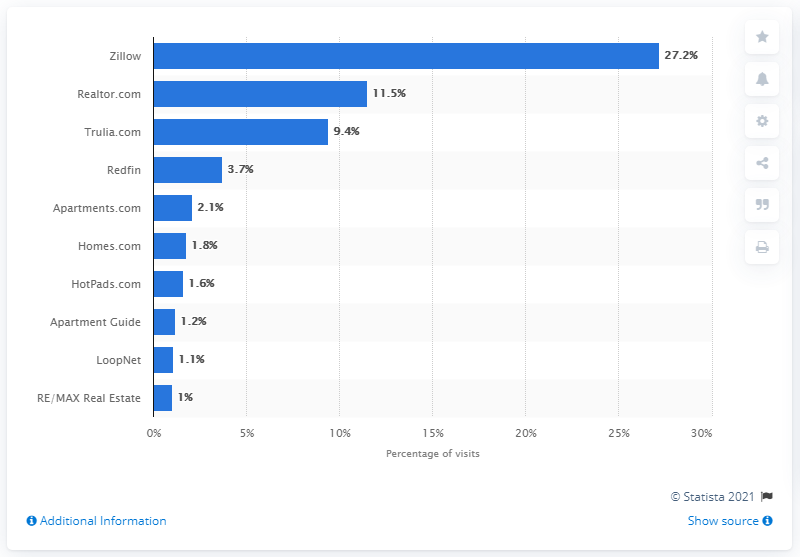Give some essential details in this illustration. In November 2016, Zillow was the market leader. 